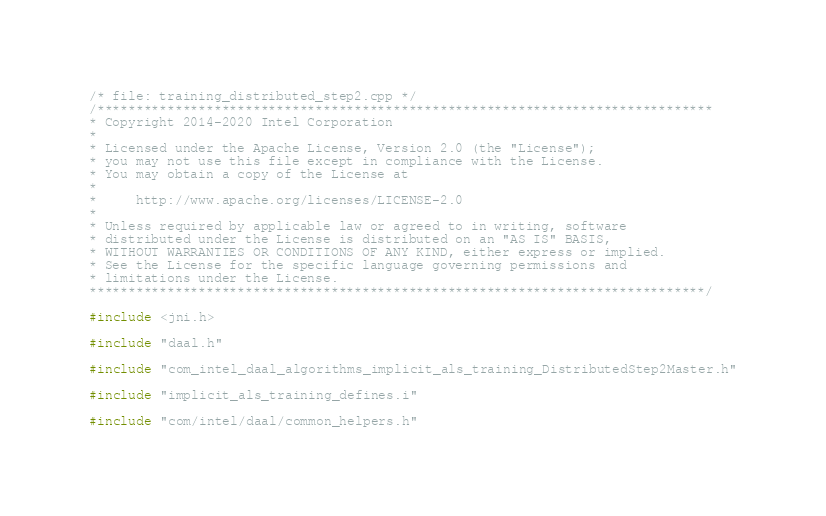Convert code to text. <code><loc_0><loc_0><loc_500><loc_500><_C++_>/* file: training_distributed_step2.cpp */
/*******************************************************************************
* Copyright 2014-2020 Intel Corporation
*
* Licensed under the Apache License, Version 2.0 (the "License");
* you may not use this file except in compliance with the License.
* You may obtain a copy of the License at
*
*     http://www.apache.org/licenses/LICENSE-2.0
*
* Unless required by applicable law or agreed to in writing, software
* distributed under the License is distributed on an "AS IS" BASIS,
* WITHOUT WARRANTIES OR CONDITIONS OF ANY KIND, either express or implied.
* See the License for the specific language governing permissions and
* limitations under the License.
*******************************************************************************/

#include <jni.h>

#include "daal.h"

#include "com_intel_daal_algorithms_implicit_als_training_DistributedStep2Master.h"

#include "implicit_als_training_defines.i"

#include "com/intel/daal/common_helpers.h"
</code> 